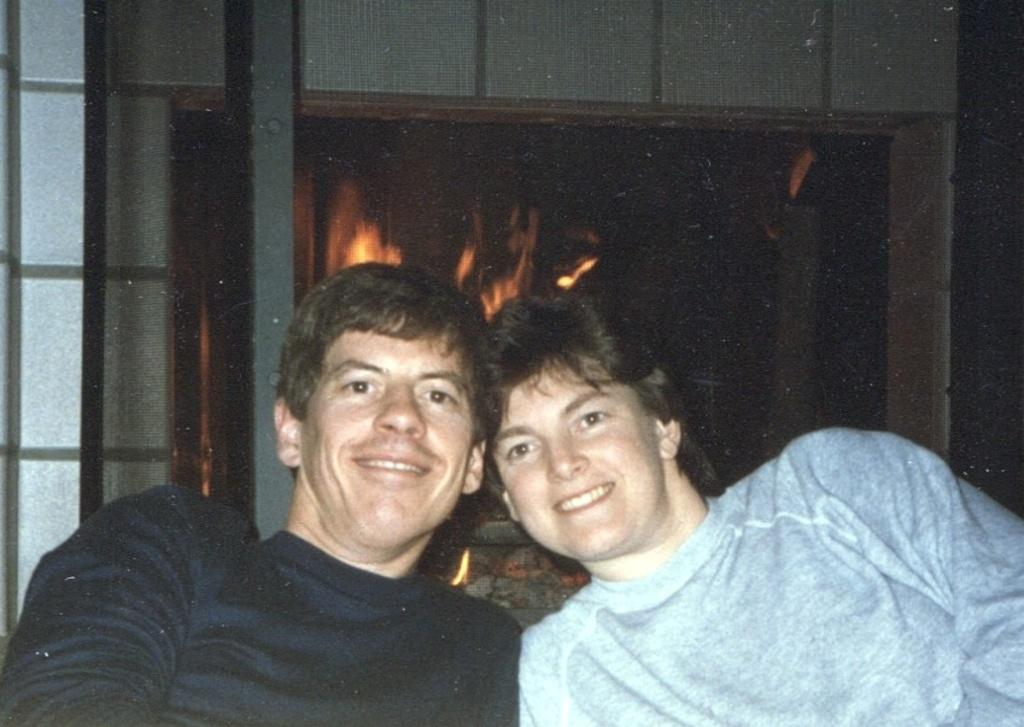How many people are in the image? There are two men in the image. What are the men doing in the image? The men are sitting and smiling. What can be seen in the background of the image? There is a fireplace in the background of the image. What is happening with the fireplace in the image? There is fire in the fireplace. What is associated with the fireplace in the image? There is a wall associated with the fireplace. What type of cream is being applied to the locket in the image? There is no cream or locket present in the image. Are the men swimming in the image? No, the men are sitting and not swimming in the image. 